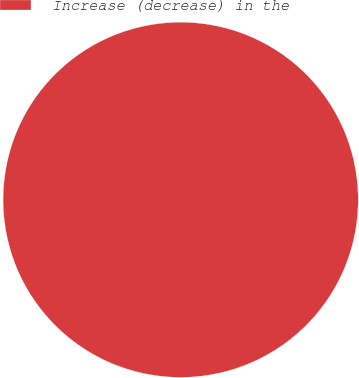Convert chart. <chart><loc_0><loc_0><loc_500><loc_500><pie_chart><fcel>Increase (decrease) in the<nl><fcel>100.0%<nl></chart> 